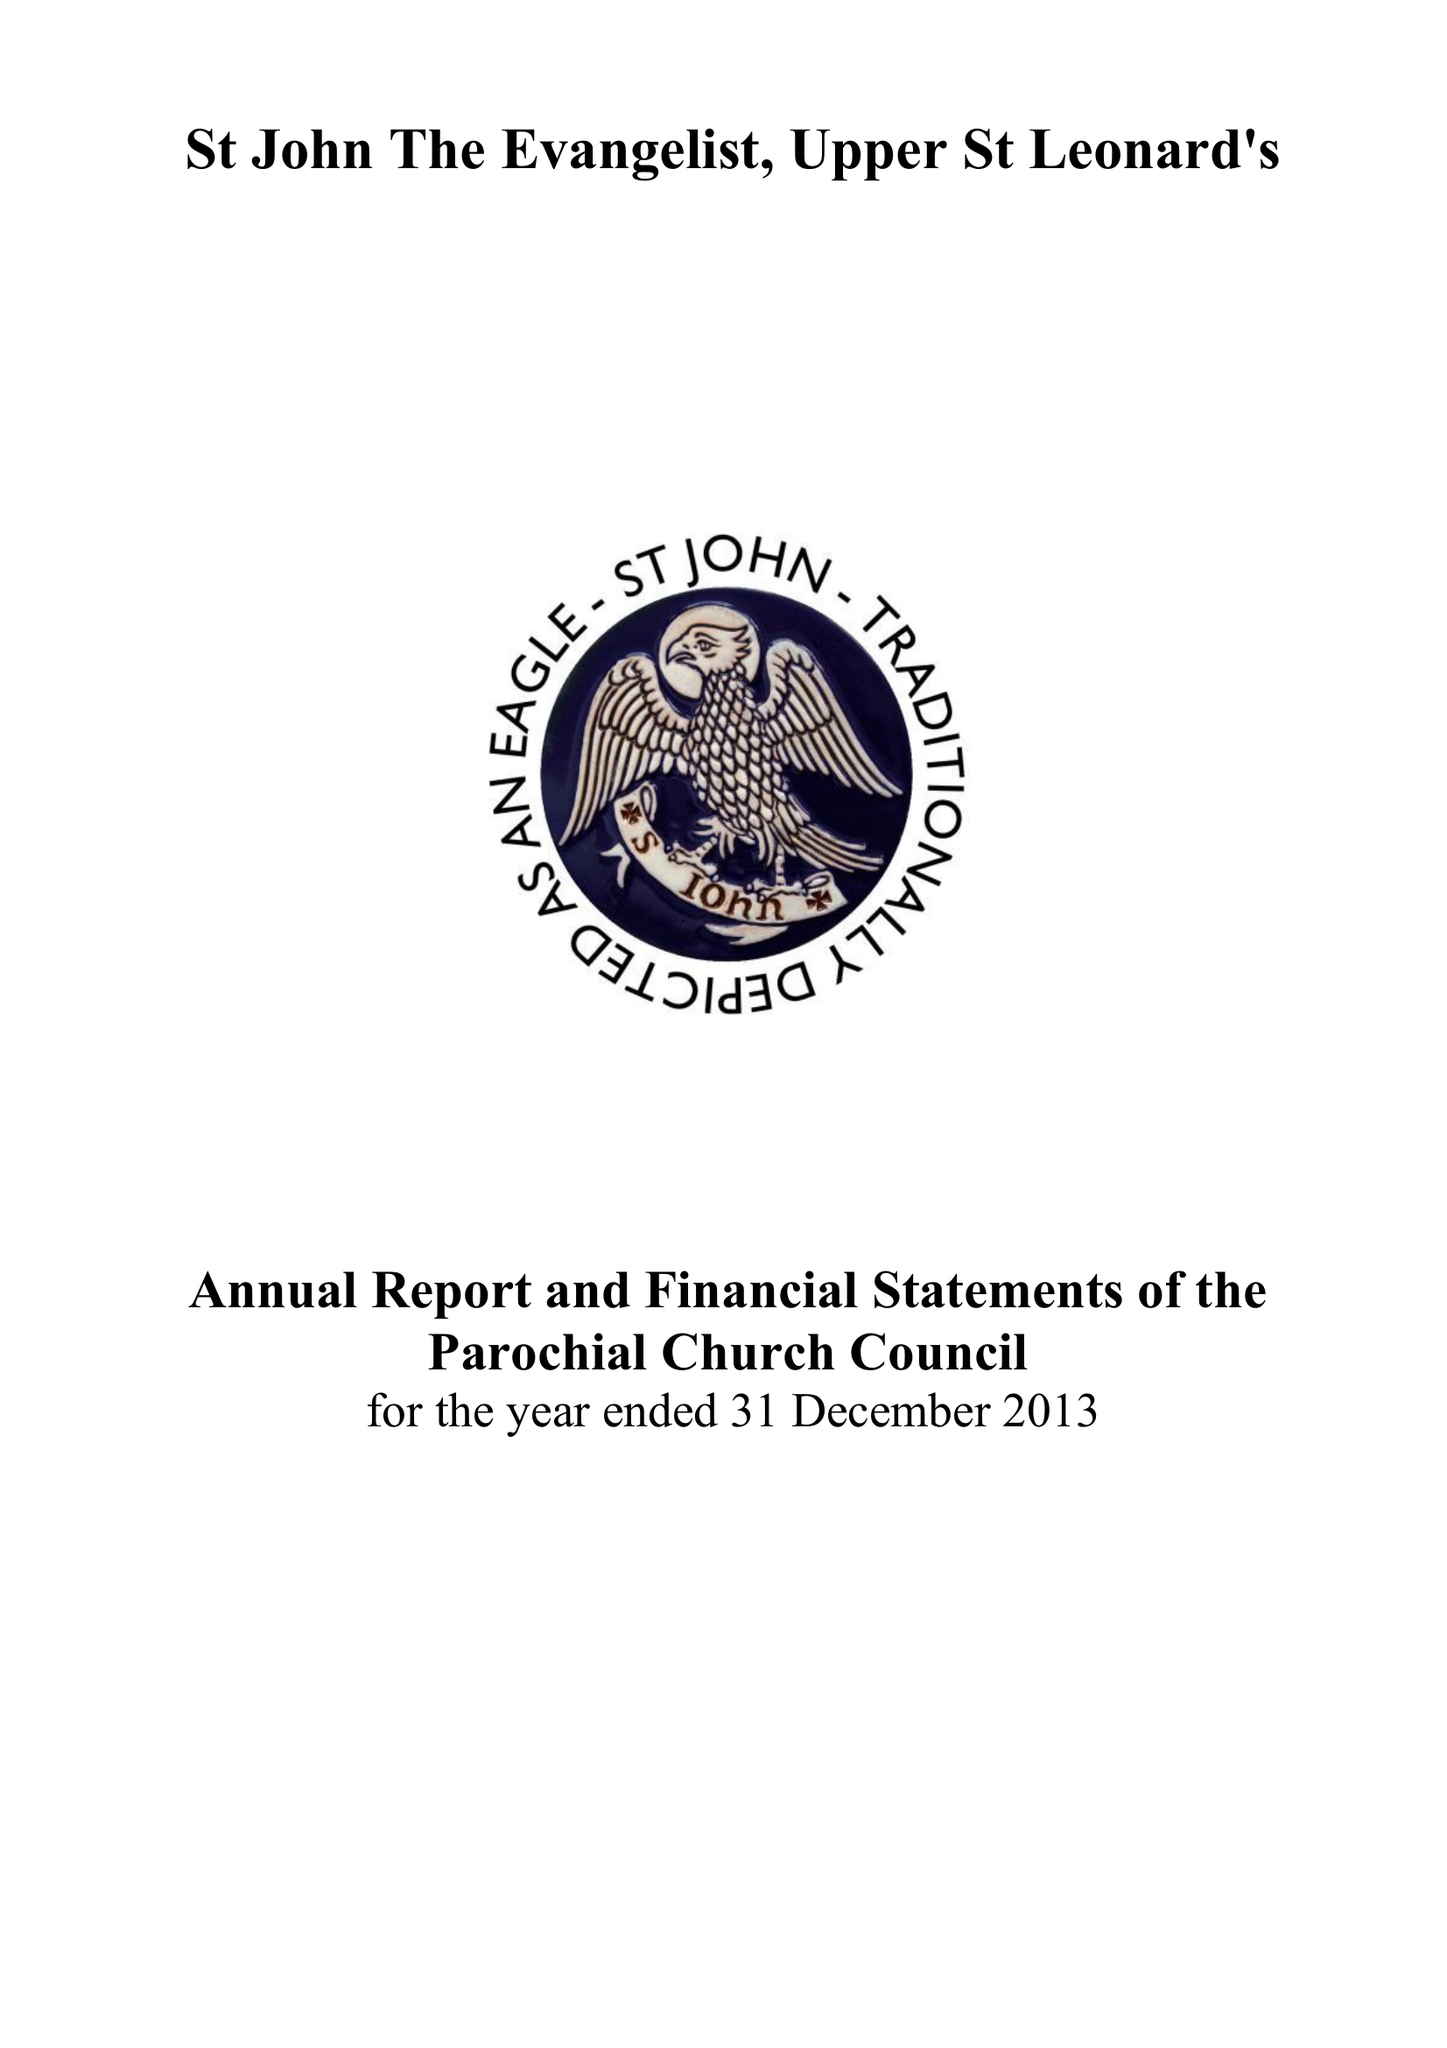What is the value for the report_date?
Answer the question using a single word or phrase. 2013-12-31 